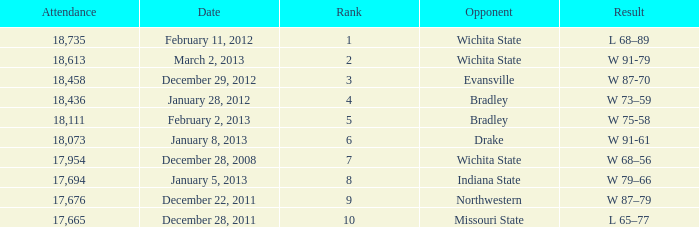What's the standing when the number of attendees was under 18,073 and with northwestern as the competitor? 9.0. Help me parse the entirety of this table. {'header': ['Attendance', 'Date', 'Rank', 'Opponent', 'Result'], 'rows': [['18,735', 'February 11, 2012', '1', 'Wichita State', 'L 68–89'], ['18,613', 'March 2, 2013', '2', 'Wichita State', 'W 91-79'], ['18,458', 'December 29, 2012', '3', 'Evansville', 'W 87-70'], ['18,436', 'January 28, 2012', '4', 'Bradley', 'W 73–59'], ['18,111', 'February 2, 2013', '5', 'Bradley', 'W 75-58'], ['18,073', 'January 8, 2013', '6', 'Drake', 'W 91-61'], ['17,954', 'December 28, 2008', '7', 'Wichita State', 'W 68–56'], ['17,694', 'January 5, 2013', '8', 'Indiana State', 'W 79–66'], ['17,676', 'December 22, 2011', '9', 'Northwestern', 'W 87–79'], ['17,665', 'December 28, 2011', '10', 'Missouri State', 'L 65–77']]} 